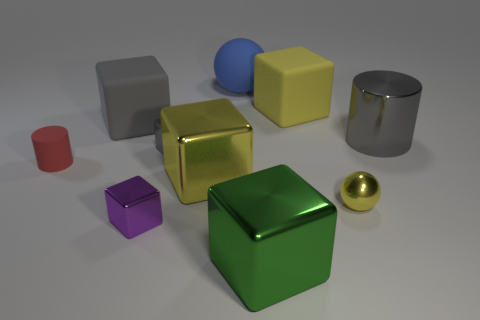What is the color of the large cylinder that is made of the same material as the purple object? gray 